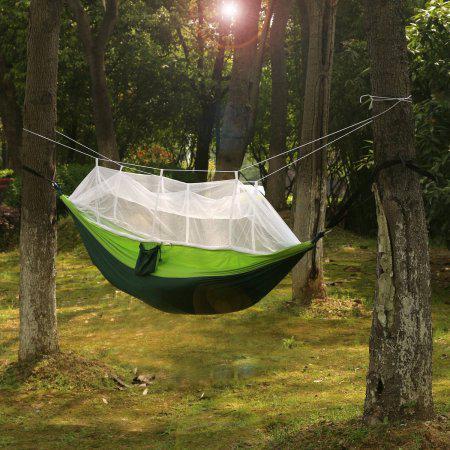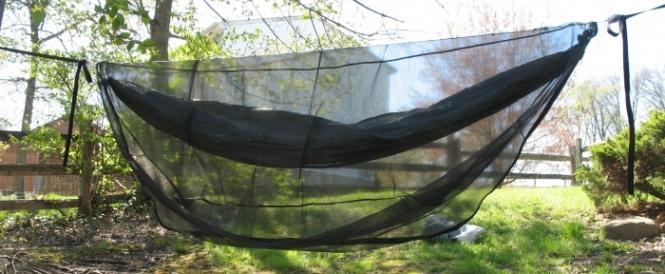The first image is the image on the left, the second image is the image on the right. For the images shown, is this caption "A person can be seen in one image of a hanging hammock with netting cover." true? Answer yes or no. No. 